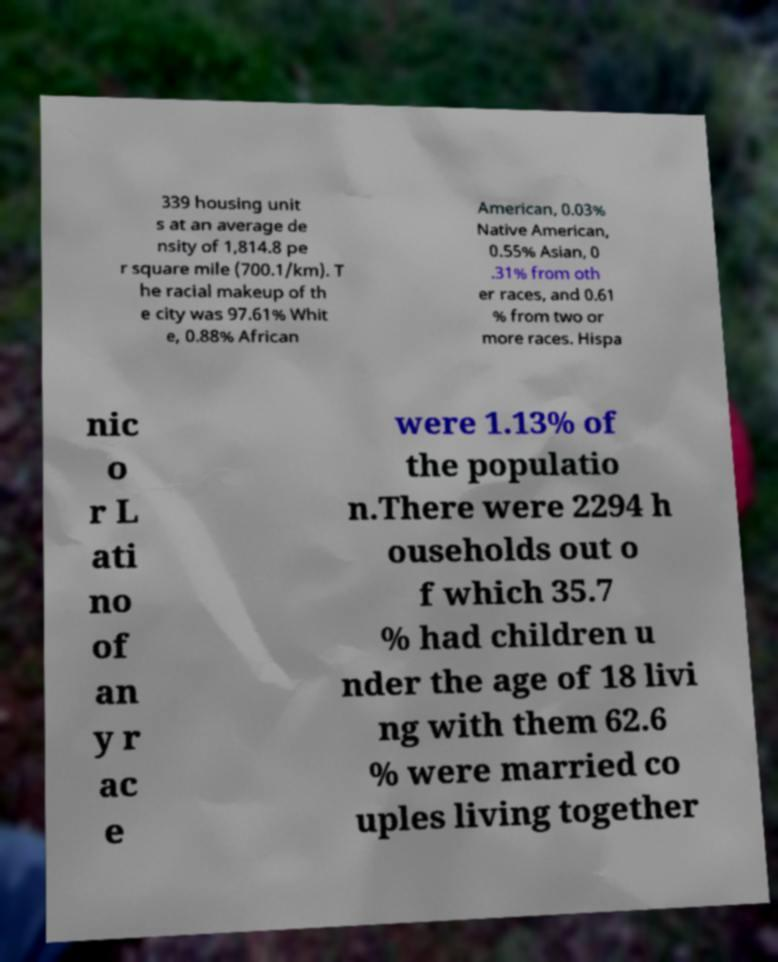Please read and relay the text visible in this image. What does it say? 339 housing unit s at an average de nsity of 1,814.8 pe r square mile (700.1/km). T he racial makeup of th e city was 97.61% Whit e, 0.88% African American, 0.03% Native American, 0.55% Asian, 0 .31% from oth er races, and 0.61 % from two or more races. Hispa nic o r L ati no of an y r ac e were 1.13% of the populatio n.There were 2294 h ouseholds out o f which 35.7 % had children u nder the age of 18 livi ng with them 62.6 % were married co uples living together 